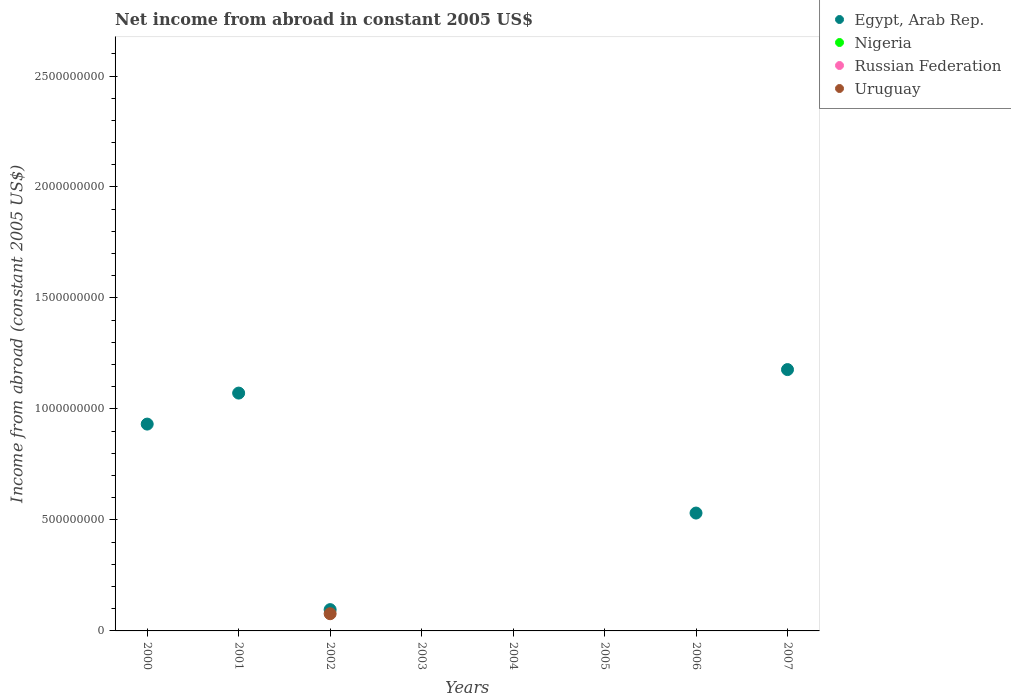How many different coloured dotlines are there?
Ensure brevity in your answer.  2. Is the number of dotlines equal to the number of legend labels?
Ensure brevity in your answer.  No. What is the net income from abroad in Nigeria in 2004?
Keep it short and to the point. 0. Across all years, what is the maximum net income from abroad in Uruguay?
Offer a terse response. 7.75e+07. What is the total net income from abroad in Nigeria in the graph?
Provide a succinct answer. 0. What is the average net income from abroad in Uruguay per year?
Give a very brief answer. 9.69e+06. In the year 2002, what is the difference between the net income from abroad in Egypt, Arab Rep. and net income from abroad in Uruguay?
Your answer should be very brief. 1.84e+07. What is the difference between the highest and the lowest net income from abroad in Uruguay?
Your response must be concise. 7.75e+07. In how many years, is the net income from abroad in Egypt, Arab Rep. greater than the average net income from abroad in Egypt, Arab Rep. taken over all years?
Give a very brief answer. 4. Is it the case that in every year, the sum of the net income from abroad in Nigeria and net income from abroad in Uruguay  is greater than the sum of net income from abroad in Egypt, Arab Rep. and net income from abroad in Russian Federation?
Your answer should be very brief. No. Is it the case that in every year, the sum of the net income from abroad in Nigeria and net income from abroad in Russian Federation  is greater than the net income from abroad in Egypt, Arab Rep.?
Provide a succinct answer. No. Does the net income from abroad in Russian Federation monotonically increase over the years?
Offer a very short reply. No. What is the difference between two consecutive major ticks on the Y-axis?
Your answer should be very brief. 5.00e+08. Does the graph contain any zero values?
Your response must be concise. Yes. Does the graph contain grids?
Keep it short and to the point. No. Where does the legend appear in the graph?
Offer a terse response. Top right. What is the title of the graph?
Offer a very short reply. Net income from abroad in constant 2005 US$. Does "Greenland" appear as one of the legend labels in the graph?
Your answer should be compact. No. What is the label or title of the Y-axis?
Your answer should be very brief. Income from abroad (constant 2005 US$). What is the Income from abroad (constant 2005 US$) in Egypt, Arab Rep. in 2000?
Ensure brevity in your answer.  9.32e+08. What is the Income from abroad (constant 2005 US$) of Russian Federation in 2000?
Your answer should be very brief. 0. What is the Income from abroad (constant 2005 US$) of Uruguay in 2000?
Your response must be concise. 0. What is the Income from abroad (constant 2005 US$) in Egypt, Arab Rep. in 2001?
Your answer should be compact. 1.07e+09. What is the Income from abroad (constant 2005 US$) in Nigeria in 2001?
Make the answer very short. 0. What is the Income from abroad (constant 2005 US$) in Russian Federation in 2001?
Provide a short and direct response. 0. What is the Income from abroad (constant 2005 US$) in Uruguay in 2001?
Give a very brief answer. 0. What is the Income from abroad (constant 2005 US$) of Egypt, Arab Rep. in 2002?
Make the answer very short. 9.59e+07. What is the Income from abroad (constant 2005 US$) of Uruguay in 2002?
Keep it short and to the point. 7.75e+07. What is the Income from abroad (constant 2005 US$) of Egypt, Arab Rep. in 2003?
Your answer should be compact. 0. What is the Income from abroad (constant 2005 US$) in Russian Federation in 2003?
Keep it short and to the point. 0. What is the Income from abroad (constant 2005 US$) of Egypt, Arab Rep. in 2004?
Your answer should be compact. 0. What is the Income from abroad (constant 2005 US$) of Nigeria in 2004?
Your response must be concise. 0. What is the Income from abroad (constant 2005 US$) in Nigeria in 2005?
Offer a very short reply. 0. What is the Income from abroad (constant 2005 US$) in Uruguay in 2005?
Your response must be concise. 0. What is the Income from abroad (constant 2005 US$) in Egypt, Arab Rep. in 2006?
Provide a succinct answer. 5.31e+08. What is the Income from abroad (constant 2005 US$) of Nigeria in 2006?
Your answer should be very brief. 0. What is the Income from abroad (constant 2005 US$) of Egypt, Arab Rep. in 2007?
Give a very brief answer. 1.18e+09. What is the Income from abroad (constant 2005 US$) in Nigeria in 2007?
Keep it short and to the point. 0. What is the Income from abroad (constant 2005 US$) in Uruguay in 2007?
Provide a short and direct response. 0. Across all years, what is the maximum Income from abroad (constant 2005 US$) in Egypt, Arab Rep.?
Make the answer very short. 1.18e+09. Across all years, what is the maximum Income from abroad (constant 2005 US$) in Uruguay?
Your response must be concise. 7.75e+07. Across all years, what is the minimum Income from abroad (constant 2005 US$) of Egypt, Arab Rep.?
Keep it short and to the point. 0. What is the total Income from abroad (constant 2005 US$) in Egypt, Arab Rep. in the graph?
Your response must be concise. 3.81e+09. What is the total Income from abroad (constant 2005 US$) of Russian Federation in the graph?
Give a very brief answer. 0. What is the total Income from abroad (constant 2005 US$) in Uruguay in the graph?
Provide a short and direct response. 7.75e+07. What is the difference between the Income from abroad (constant 2005 US$) in Egypt, Arab Rep. in 2000 and that in 2001?
Your answer should be very brief. -1.40e+08. What is the difference between the Income from abroad (constant 2005 US$) in Egypt, Arab Rep. in 2000 and that in 2002?
Give a very brief answer. 8.36e+08. What is the difference between the Income from abroad (constant 2005 US$) in Egypt, Arab Rep. in 2000 and that in 2006?
Offer a terse response. 4.01e+08. What is the difference between the Income from abroad (constant 2005 US$) of Egypt, Arab Rep. in 2000 and that in 2007?
Your answer should be compact. -2.46e+08. What is the difference between the Income from abroad (constant 2005 US$) of Egypt, Arab Rep. in 2001 and that in 2002?
Give a very brief answer. 9.76e+08. What is the difference between the Income from abroad (constant 2005 US$) of Egypt, Arab Rep. in 2001 and that in 2006?
Provide a succinct answer. 5.41e+08. What is the difference between the Income from abroad (constant 2005 US$) in Egypt, Arab Rep. in 2001 and that in 2007?
Give a very brief answer. -1.06e+08. What is the difference between the Income from abroad (constant 2005 US$) in Egypt, Arab Rep. in 2002 and that in 2006?
Offer a very short reply. -4.35e+08. What is the difference between the Income from abroad (constant 2005 US$) of Egypt, Arab Rep. in 2002 and that in 2007?
Your answer should be very brief. -1.08e+09. What is the difference between the Income from abroad (constant 2005 US$) of Egypt, Arab Rep. in 2006 and that in 2007?
Your answer should be compact. -6.46e+08. What is the difference between the Income from abroad (constant 2005 US$) in Egypt, Arab Rep. in 2000 and the Income from abroad (constant 2005 US$) in Uruguay in 2002?
Offer a very short reply. 8.54e+08. What is the difference between the Income from abroad (constant 2005 US$) of Egypt, Arab Rep. in 2001 and the Income from abroad (constant 2005 US$) of Uruguay in 2002?
Keep it short and to the point. 9.94e+08. What is the average Income from abroad (constant 2005 US$) in Egypt, Arab Rep. per year?
Provide a succinct answer. 4.76e+08. What is the average Income from abroad (constant 2005 US$) in Nigeria per year?
Your answer should be compact. 0. What is the average Income from abroad (constant 2005 US$) in Russian Federation per year?
Your answer should be very brief. 0. What is the average Income from abroad (constant 2005 US$) in Uruguay per year?
Your answer should be compact. 9.69e+06. In the year 2002, what is the difference between the Income from abroad (constant 2005 US$) of Egypt, Arab Rep. and Income from abroad (constant 2005 US$) of Uruguay?
Provide a succinct answer. 1.84e+07. What is the ratio of the Income from abroad (constant 2005 US$) in Egypt, Arab Rep. in 2000 to that in 2001?
Ensure brevity in your answer.  0.87. What is the ratio of the Income from abroad (constant 2005 US$) of Egypt, Arab Rep. in 2000 to that in 2002?
Your answer should be very brief. 9.71. What is the ratio of the Income from abroad (constant 2005 US$) in Egypt, Arab Rep. in 2000 to that in 2006?
Offer a very short reply. 1.75. What is the ratio of the Income from abroad (constant 2005 US$) of Egypt, Arab Rep. in 2000 to that in 2007?
Keep it short and to the point. 0.79. What is the ratio of the Income from abroad (constant 2005 US$) of Egypt, Arab Rep. in 2001 to that in 2002?
Your answer should be compact. 11.17. What is the ratio of the Income from abroad (constant 2005 US$) of Egypt, Arab Rep. in 2001 to that in 2006?
Give a very brief answer. 2.02. What is the ratio of the Income from abroad (constant 2005 US$) of Egypt, Arab Rep. in 2001 to that in 2007?
Ensure brevity in your answer.  0.91. What is the ratio of the Income from abroad (constant 2005 US$) in Egypt, Arab Rep. in 2002 to that in 2006?
Offer a terse response. 0.18. What is the ratio of the Income from abroad (constant 2005 US$) of Egypt, Arab Rep. in 2002 to that in 2007?
Your answer should be very brief. 0.08. What is the ratio of the Income from abroad (constant 2005 US$) of Egypt, Arab Rep. in 2006 to that in 2007?
Make the answer very short. 0.45. What is the difference between the highest and the second highest Income from abroad (constant 2005 US$) in Egypt, Arab Rep.?
Keep it short and to the point. 1.06e+08. What is the difference between the highest and the lowest Income from abroad (constant 2005 US$) in Egypt, Arab Rep.?
Give a very brief answer. 1.18e+09. What is the difference between the highest and the lowest Income from abroad (constant 2005 US$) of Uruguay?
Your answer should be very brief. 7.75e+07. 